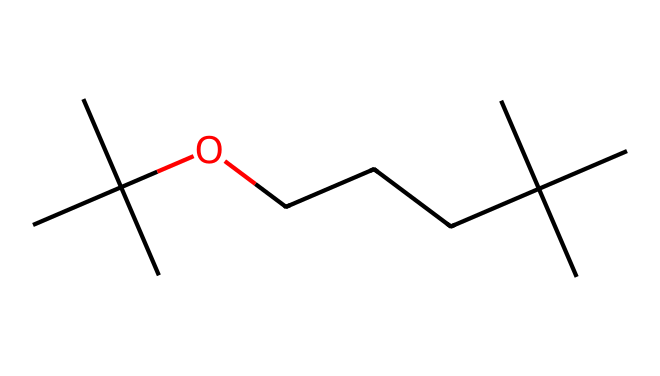What is the highest number of carbon atoms in this molecule? Counting the carbon atoms in the SMILES representation, which indicates branching and linear structures, shows there are a total of 12 carbon atoms in the molecular structure.
Answer: 12 How many oxygen atoms are in the structure? The SMILES representation shows only one oxygen atom present, as denoted by the letter "O" in the chain.
Answer: 1 What type of chemical is this molecule primarily classified as? Given its structure with multiple carbon configurations, branching, and presence of oxygen, this molecule can be classified as a tertiary alcohol.
Answer: tertiary alcohol Does this molecule contain any double or triple bonds? The SMILES does not indicate any double (C=C) or triple (C≡C) bonds; only single bonds are present throughout the structure, as indicated by the linear representation without annotations for double or triple bonds.
Answer: No What forces dominate the interactions in solid forms of this additive? In solid-form fuel additives like this one, dispersive forces (London dispersion forces) and dipole-dipole interactions due to its polar alcohol functionality predominantly govern the intermolecular interactions.
Answer: dispersive forces What is a likely physical property of this fuel additive based on its structure? The presence of branching and the hydroxyl group suggest that this molecule likely has a lower boiling point compared to straight-chain alcohols of similar molecular weight due to reduced van der Waals forces and steric hindrance.
Answer: lower boiling point 